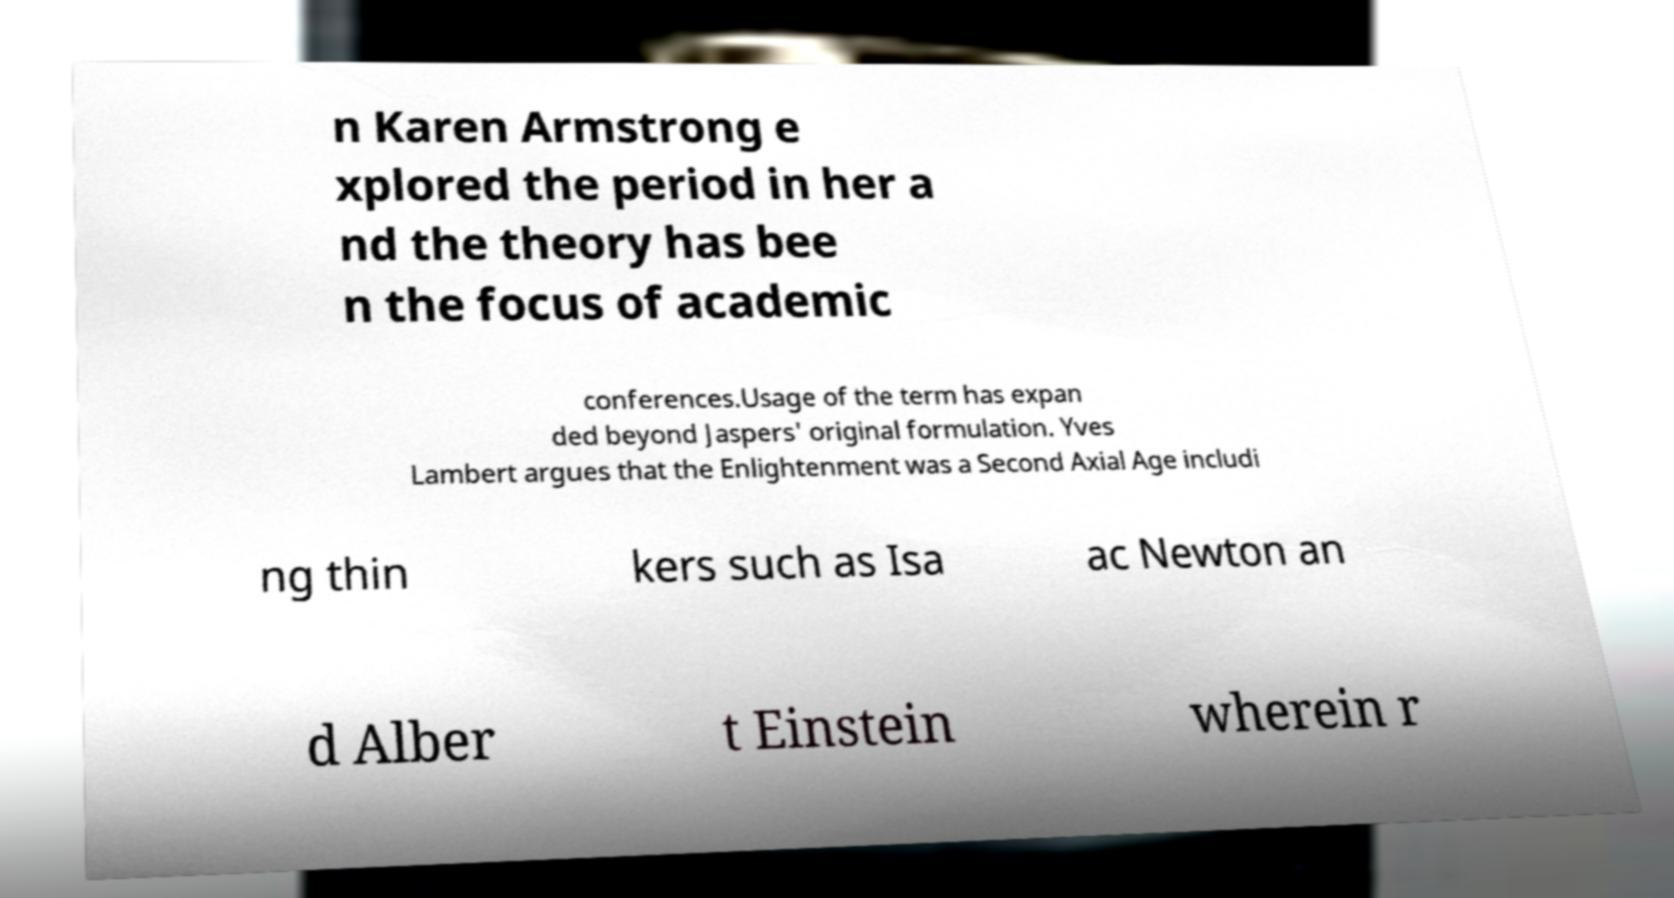Please identify and transcribe the text found in this image. n Karen Armstrong e xplored the period in her a nd the theory has bee n the focus of academic conferences.Usage of the term has expan ded beyond Jaspers' original formulation. Yves Lambert argues that the Enlightenment was a Second Axial Age includi ng thin kers such as Isa ac Newton an d Alber t Einstein wherein r 